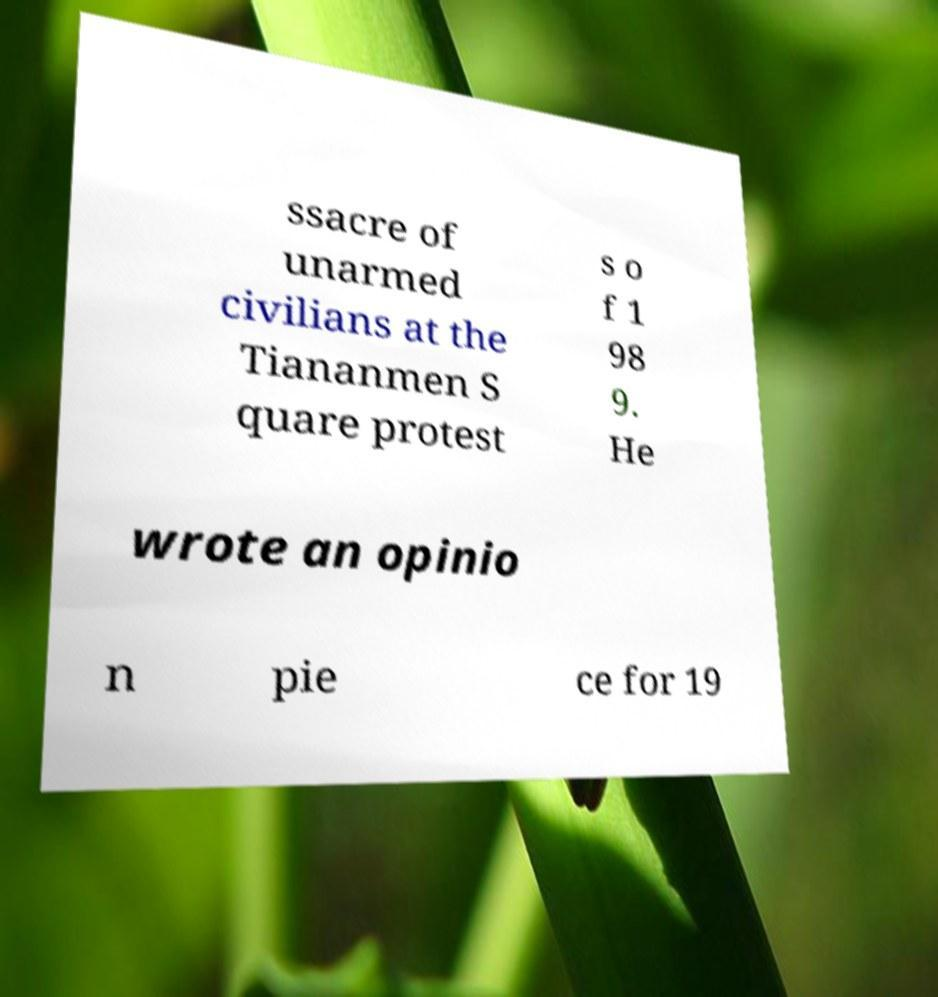Can you accurately transcribe the text from the provided image for me? ssacre of unarmed civilians at the Tiananmen S quare protest s o f 1 98 9. He wrote an opinio n pie ce for 19 